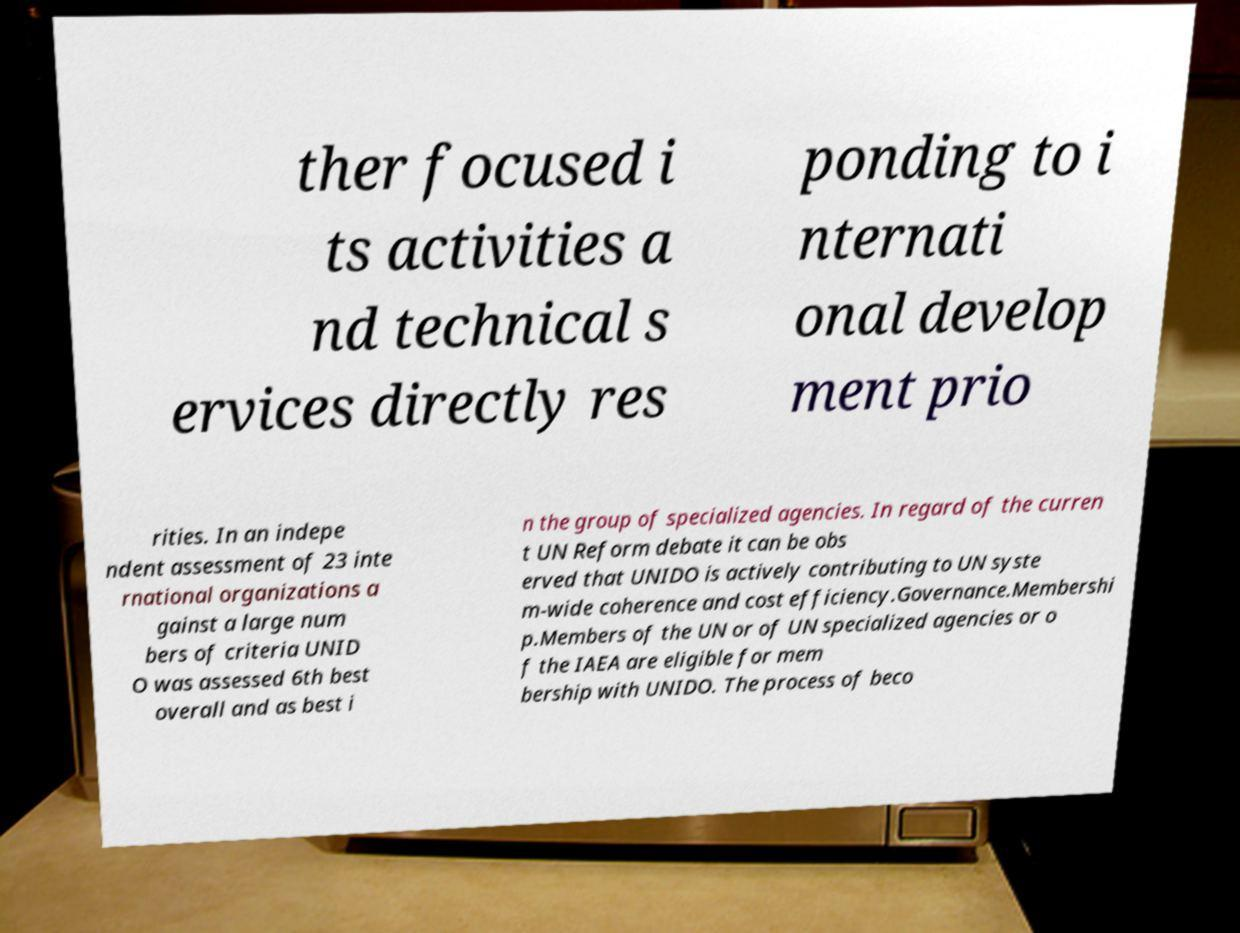There's text embedded in this image that I need extracted. Can you transcribe it verbatim? ther focused i ts activities a nd technical s ervices directly res ponding to i nternati onal develop ment prio rities. In an indepe ndent assessment of 23 inte rnational organizations a gainst a large num bers of criteria UNID O was assessed 6th best overall and as best i n the group of specialized agencies. In regard of the curren t UN Reform debate it can be obs erved that UNIDO is actively contributing to UN syste m-wide coherence and cost efficiency.Governance.Membershi p.Members of the UN or of UN specialized agencies or o f the IAEA are eligible for mem bership with UNIDO. The process of beco 